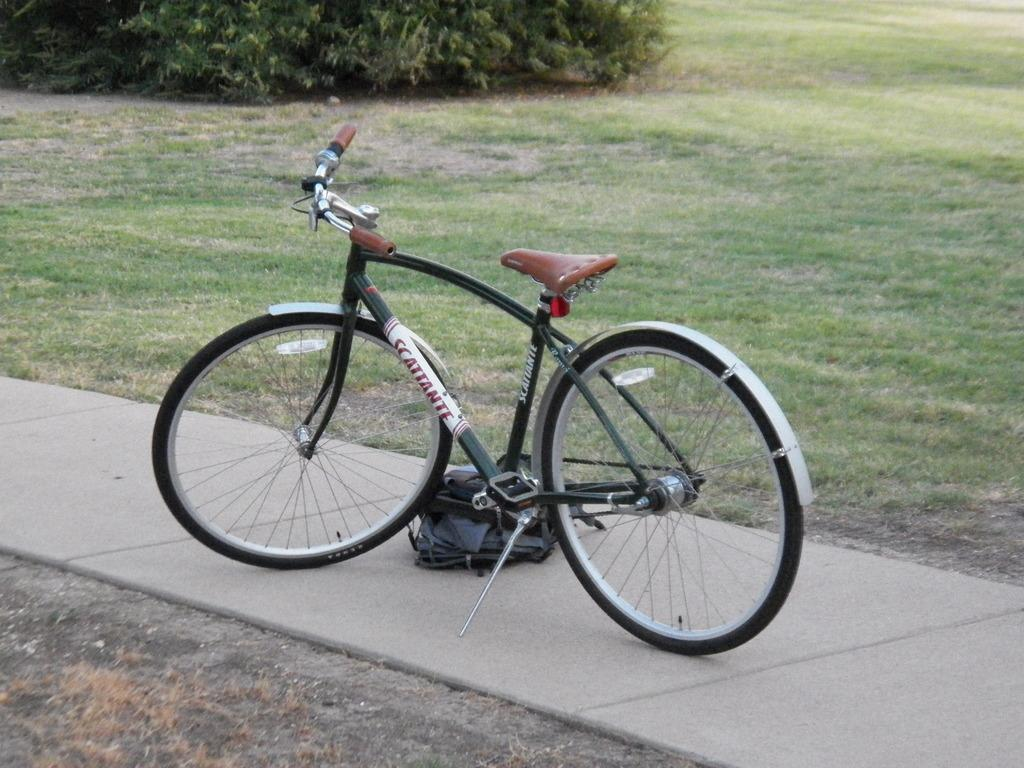What is the main object in the image? There is a bicycle in the image. Where is the bicycle located? The bicycle is parked on a walkway. What can be seen in the background of the image? There is grass and plants in the backdrop of the image. What type of scarf is the bicycle wearing in the image? There is no scarf present in the image, as bicycles do not wear scarves. 